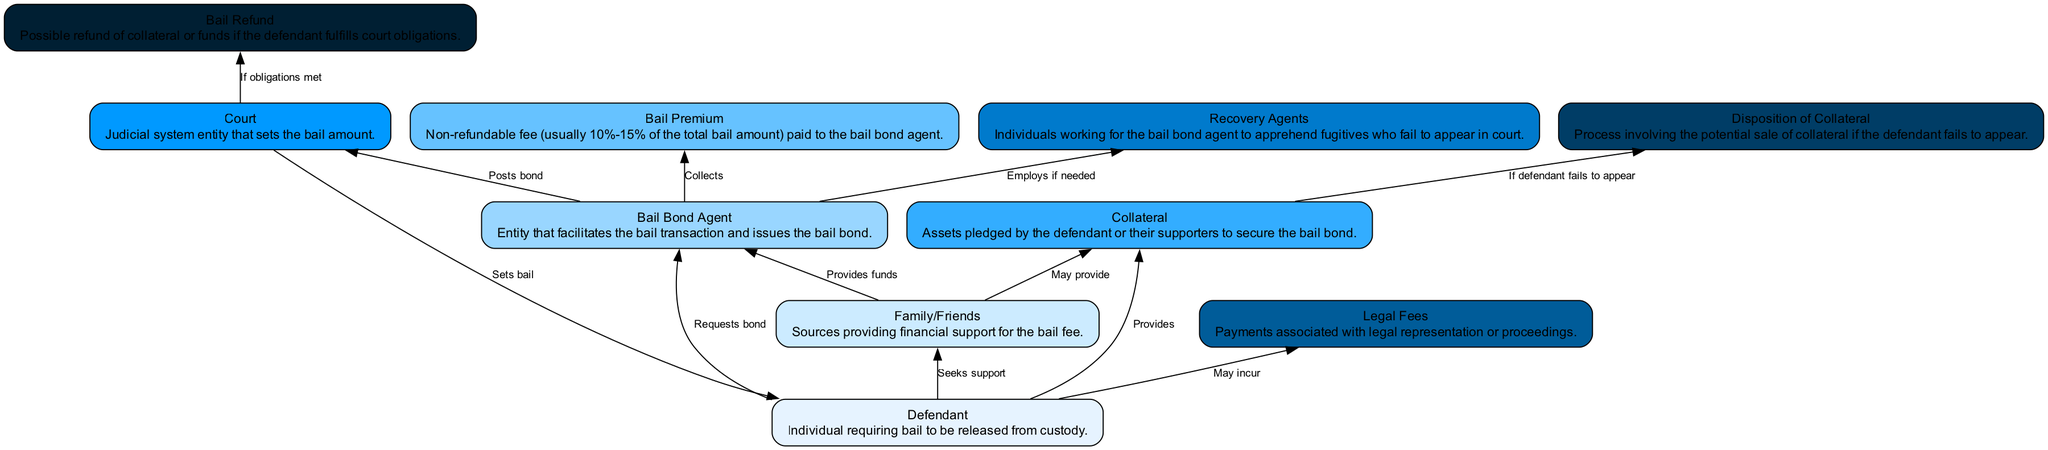What is the role of the "Defendant" in this flow chart? The "Defendant" is the individual requiring bail to be released from custody, serving as the starting point of the transaction.
Answer: Individual requiring bail How many nodes are in the diagram? The diagram contains ten nodes representing different entities involved in the bail bond transaction process.
Answer: Ten What does the "Bail Bond Agent" collect from the "Defendant"? The "Bail Bond Agent" collects the "Bail Premium," which is a non-refundable fee paid for the bail bond service.
Answer: Bail Premium What happens if the "Defendant" does not appear in court? If the "Defendant" fails to appear in court, the process involves the "Disposition of Collateral," which may include selling assets pledged as collateral.
Answer: Disposition of Collateral Which entity sets the bail amount? The entity that sets the bail amount is the "Court," as indicated in the flow of the diagram.
Answer: Court Who provides financial support to the "Defendant"? The financial support for the "Defendant" comes from "Family/Friends," who may help with the bail payment.
Answer: Family/Friends What connects the "Bail Bond Agent" and the "Recovery Agents"? The "Bail Bond Agent" employs the "Recovery Agents" if needed to apprehend fugitives who fail to appear in court.
Answer: Employs if needed What is a "Bail Refund"? A "Bail Refund" is the possible return of collateral or funds if the "Defendant" fulfills court obligations, indicated by the connection coming from the "Court."
Answer: Possible refund of collateral What relationship exists between "Collateral" and "Disposition of Collateral"? The relationship indicates that if the "Defendant" fails to appear, the "Collateral" may be subject to disposition, which can involve selling the pledged assets.
Answer: If defendant fails to appear 